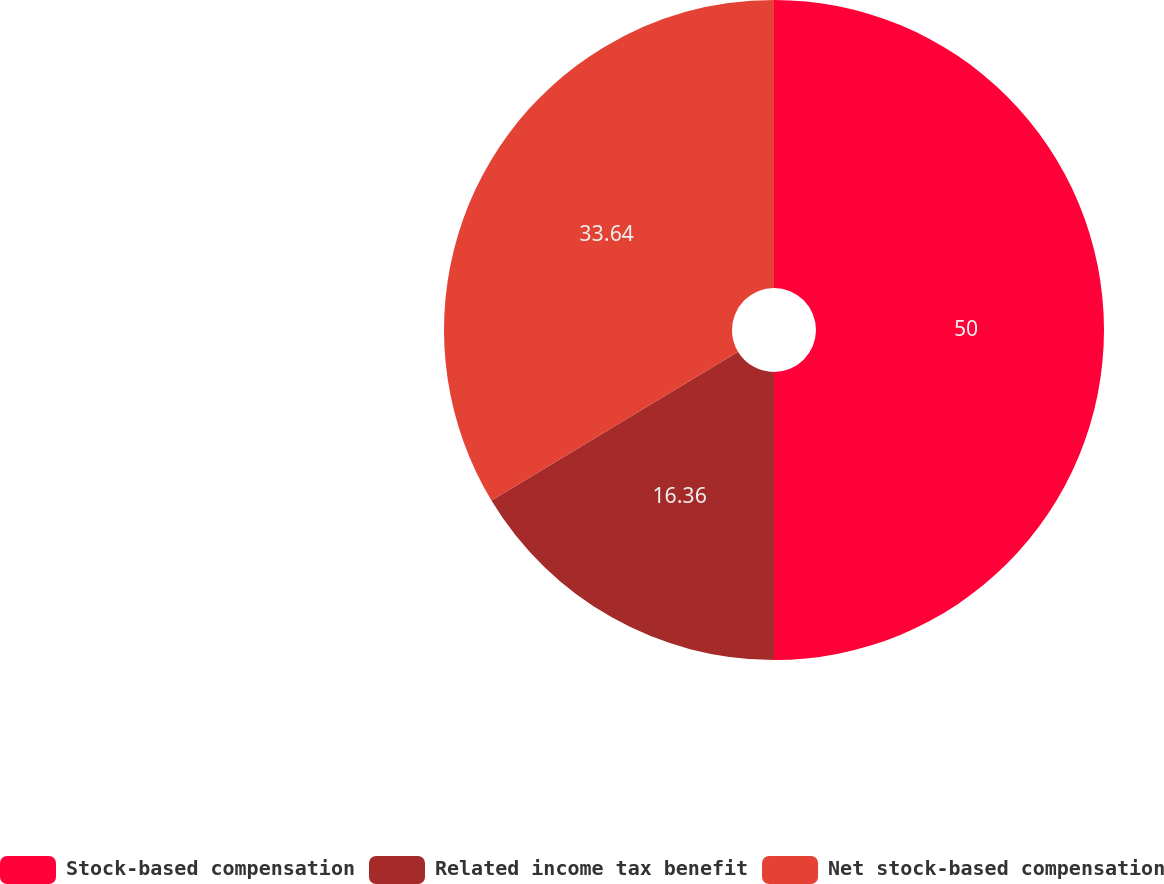Convert chart. <chart><loc_0><loc_0><loc_500><loc_500><pie_chart><fcel>Stock-based compensation<fcel>Related income tax benefit<fcel>Net stock-based compensation<nl><fcel>50.0%<fcel>16.36%<fcel>33.64%<nl></chart> 